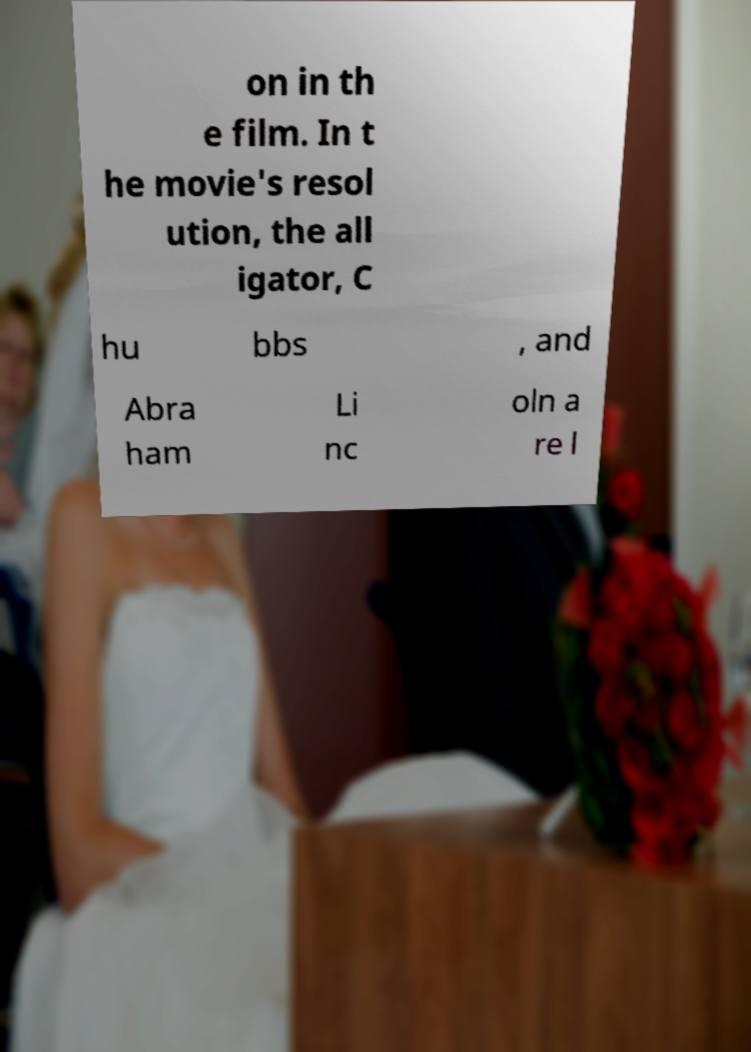For documentation purposes, I need the text within this image transcribed. Could you provide that? on in th e film. In t he movie's resol ution, the all igator, C hu bbs , and Abra ham Li nc oln a re l 